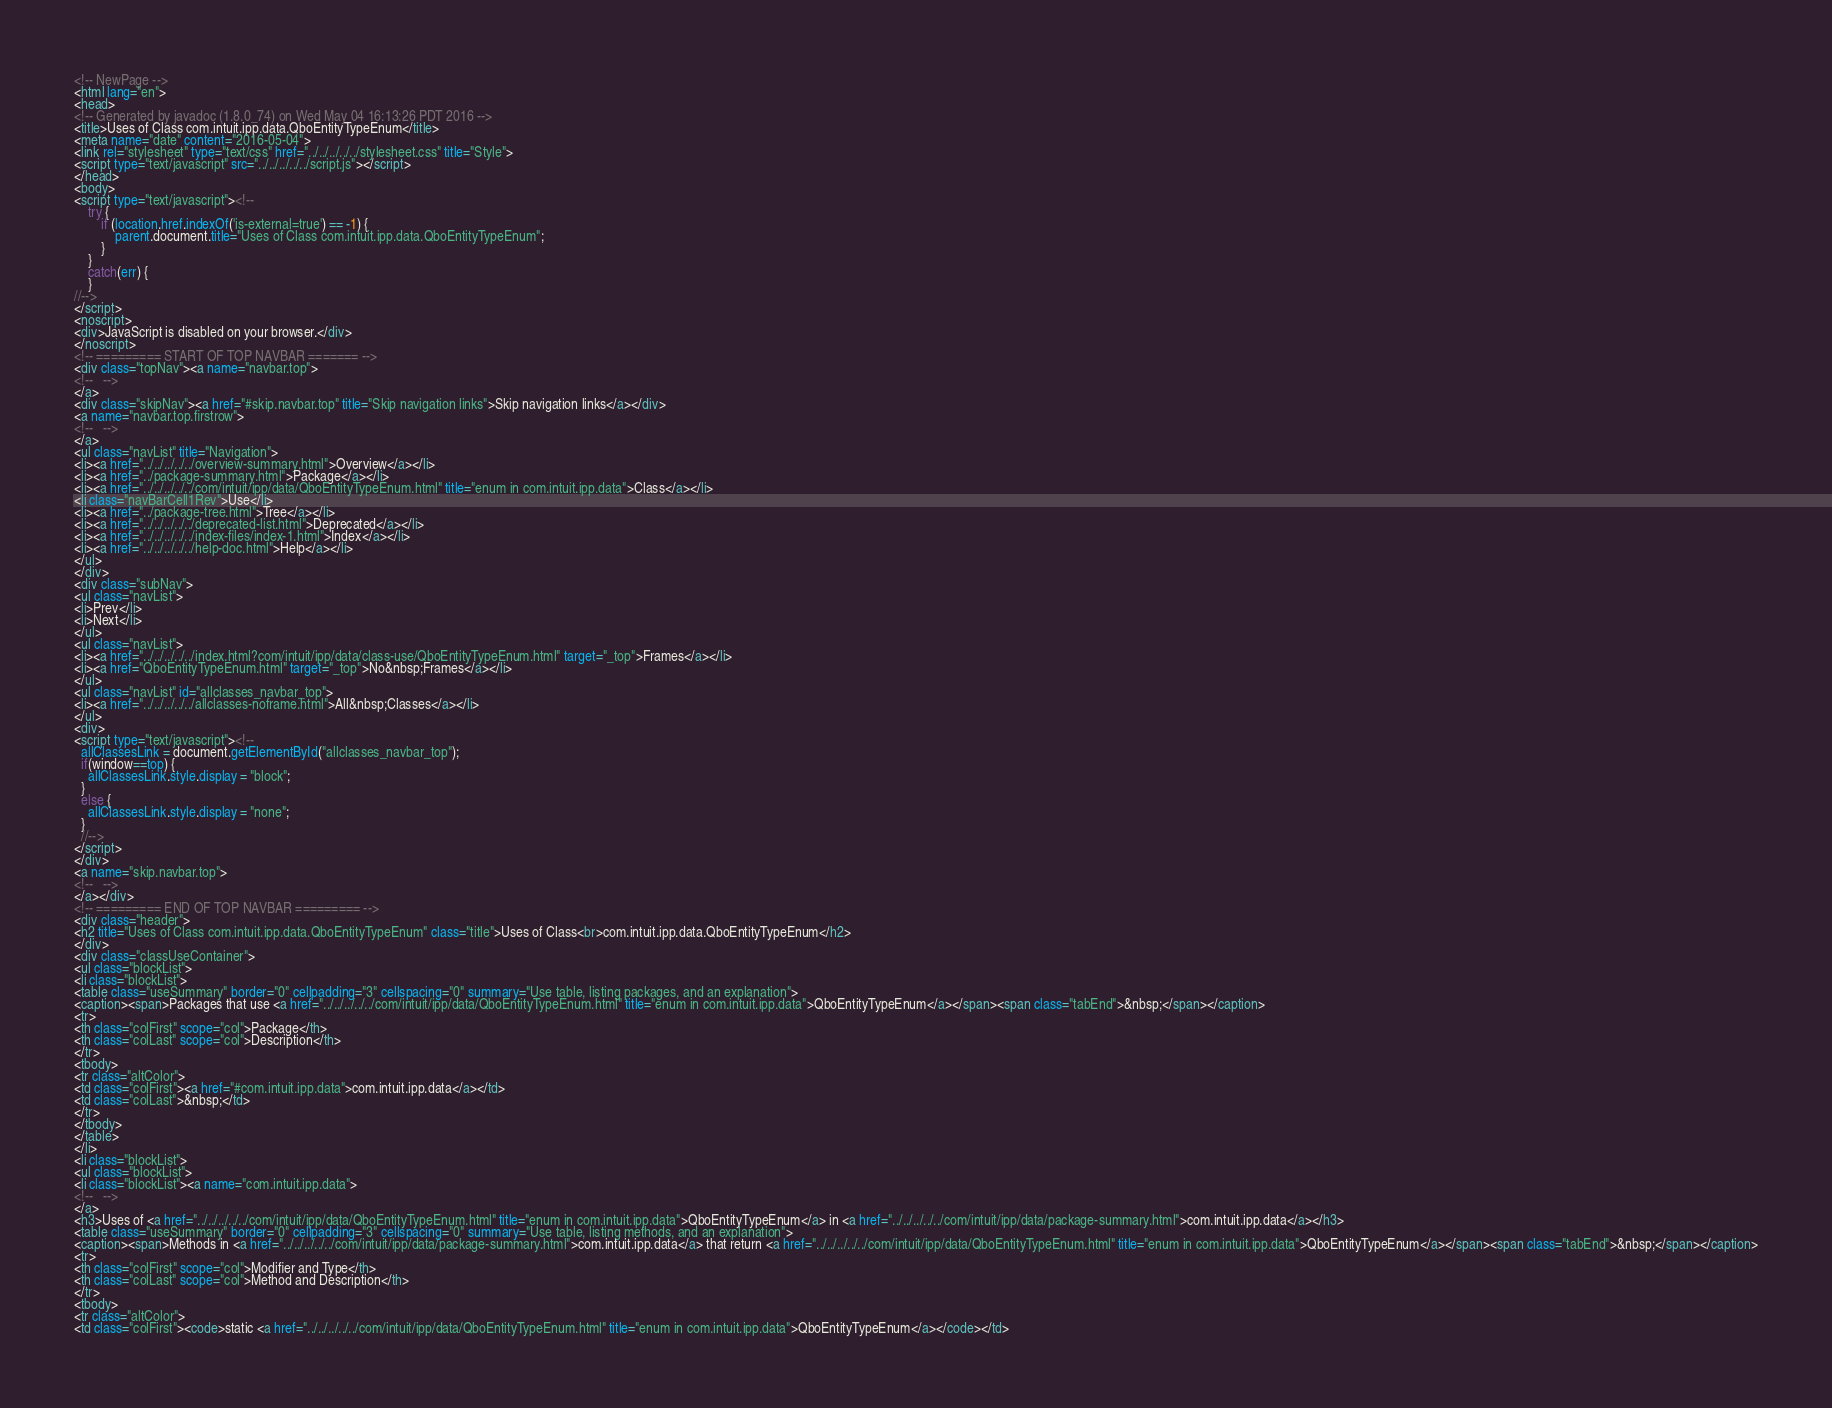<code> <loc_0><loc_0><loc_500><loc_500><_HTML_><!-- NewPage -->
<html lang="en">
<head>
<!-- Generated by javadoc (1.8.0_74) on Wed May 04 16:13:26 PDT 2016 -->
<title>Uses of Class com.intuit.ipp.data.QboEntityTypeEnum</title>
<meta name="date" content="2016-05-04">
<link rel="stylesheet" type="text/css" href="../../../../../stylesheet.css" title="Style">
<script type="text/javascript" src="../../../../../script.js"></script>
</head>
<body>
<script type="text/javascript"><!--
    try {
        if (location.href.indexOf('is-external=true') == -1) {
            parent.document.title="Uses of Class com.intuit.ipp.data.QboEntityTypeEnum";
        }
    }
    catch(err) {
    }
//-->
</script>
<noscript>
<div>JavaScript is disabled on your browser.</div>
</noscript>
<!-- ========= START OF TOP NAVBAR ======= -->
<div class="topNav"><a name="navbar.top">
<!--   -->
</a>
<div class="skipNav"><a href="#skip.navbar.top" title="Skip navigation links">Skip navigation links</a></div>
<a name="navbar.top.firstrow">
<!--   -->
</a>
<ul class="navList" title="Navigation">
<li><a href="../../../../../overview-summary.html">Overview</a></li>
<li><a href="../package-summary.html">Package</a></li>
<li><a href="../../../../../com/intuit/ipp/data/QboEntityTypeEnum.html" title="enum in com.intuit.ipp.data">Class</a></li>
<li class="navBarCell1Rev">Use</li>
<li><a href="../package-tree.html">Tree</a></li>
<li><a href="../../../../../deprecated-list.html">Deprecated</a></li>
<li><a href="../../../../../index-files/index-1.html">Index</a></li>
<li><a href="../../../../../help-doc.html">Help</a></li>
</ul>
</div>
<div class="subNav">
<ul class="navList">
<li>Prev</li>
<li>Next</li>
</ul>
<ul class="navList">
<li><a href="../../../../../index.html?com/intuit/ipp/data/class-use/QboEntityTypeEnum.html" target="_top">Frames</a></li>
<li><a href="QboEntityTypeEnum.html" target="_top">No&nbsp;Frames</a></li>
</ul>
<ul class="navList" id="allclasses_navbar_top">
<li><a href="../../../../../allclasses-noframe.html">All&nbsp;Classes</a></li>
</ul>
<div>
<script type="text/javascript"><!--
  allClassesLink = document.getElementById("allclasses_navbar_top");
  if(window==top) {
    allClassesLink.style.display = "block";
  }
  else {
    allClassesLink.style.display = "none";
  }
  //-->
</script>
</div>
<a name="skip.navbar.top">
<!--   -->
</a></div>
<!-- ========= END OF TOP NAVBAR ========= -->
<div class="header">
<h2 title="Uses of Class com.intuit.ipp.data.QboEntityTypeEnum" class="title">Uses of Class<br>com.intuit.ipp.data.QboEntityTypeEnum</h2>
</div>
<div class="classUseContainer">
<ul class="blockList">
<li class="blockList">
<table class="useSummary" border="0" cellpadding="3" cellspacing="0" summary="Use table, listing packages, and an explanation">
<caption><span>Packages that use <a href="../../../../../com/intuit/ipp/data/QboEntityTypeEnum.html" title="enum in com.intuit.ipp.data">QboEntityTypeEnum</a></span><span class="tabEnd">&nbsp;</span></caption>
<tr>
<th class="colFirst" scope="col">Package</th>
<th class="colLast" scope="col">Description</th>
</tr>
<tbody>
<tr class="altColor">
<td class="colFirst"><a href="#com.intuit.ipp.data">com.intuit.ipp.data</a></td>
<td class="colLast">&nbsp;</td>
</tr>
</tbody>
</table>
</li>
<li class="blockList">
<ul class="blockList">
<li class="blockList"><a name="com.intuit.ipp.data">
<!--   -->
</a>
<h3>Uses of <a href="../../../../../com/intuit/ipp/data/QboEntityTypeEnum.html" title="enum in com.intuit.ipp.data">QboEntityTypeEnum</a> in <a href="../../../../../com/intuit/ipp/data/package-summary.html">com.intuit.ipp.data</a></h3>
<table class="useSummary" border="0" cellpadding="3" cellspacing="0" summary="Use table, listing methods, and an explanation">
<caption><span>Methods in <a href="../../../../../com/intuit/ipp/data/package-summary.html">com.intuit.ipp.data</a> that return <a href="../../../../../com/intuit/ipp/data/QboEntityTypeEnum.html" title="enum in com.intuit.ipp.data">QboEntityTypeEnum</a></span><span class="tabEnd">&nbsp;</span></caption>
<tr>
<th class="colFirst" scope="col">Modifier and Type</th>
<th class="colLast" scope="col">Method and Description</th>
</tr>
<tbody>
<tr class="altColor">
<td class="colFirst"><code>static <a href="../../../../../com/intuit/ipp/data/QboEntityTypeEnum.html" title="enum in com.intuit.ipp.data">QboEntityTypeEnum</a></code></td></code> 